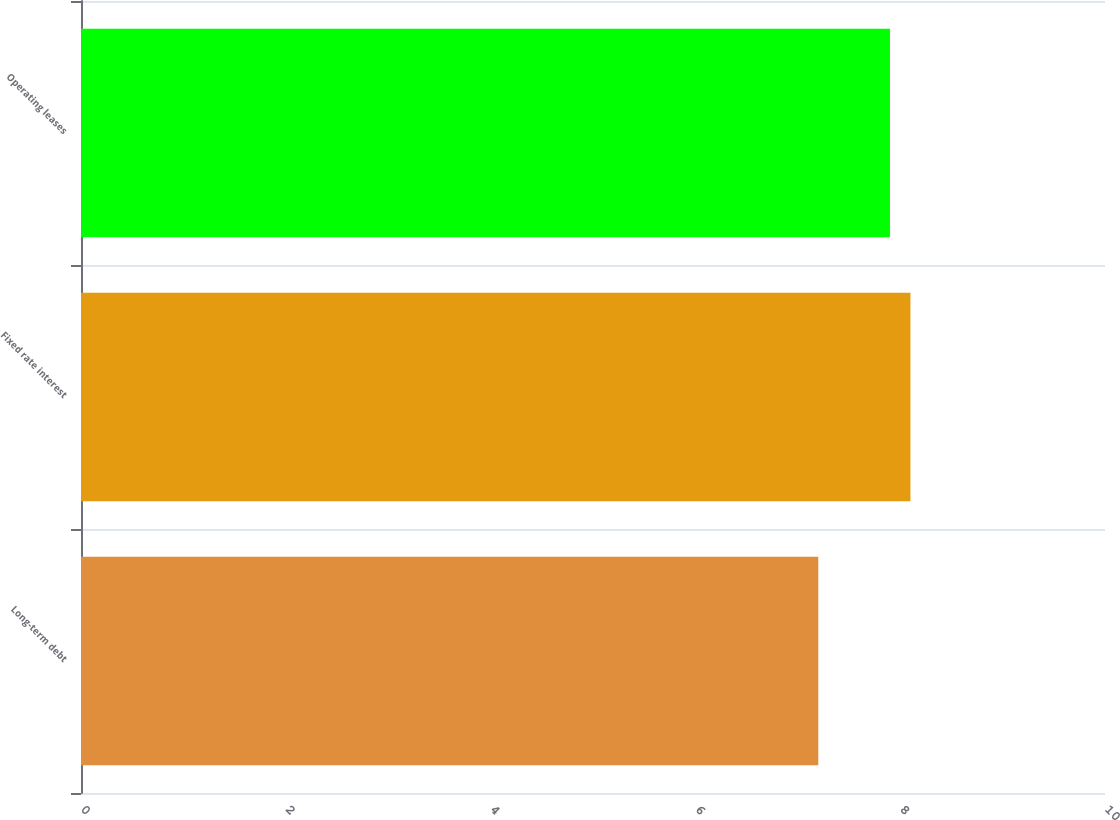Convert chart. <chart><loc_0><loc_0><loc_500><loc_500><bar_chart><fcel>Long-term debt<fcel>Fixed rate interest<fcel>Operating leases<nl><fcel>7.2<fcel>8.1<fcel>7.9<nl></chart> 